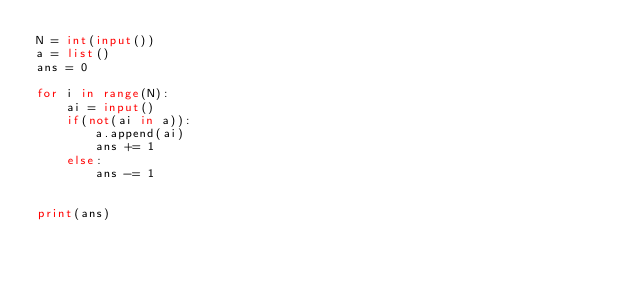<code> <loc_0><loc_0><loc_500><loc_500><_Python_>N = int(input())
a = list()
ans = 0

for i in range(N):
    ai = input()
    if(not(ai in a)):
        a.append(ai)
        ans += 1
    else:
        ans -= 1
        

print(ans)
</code> 